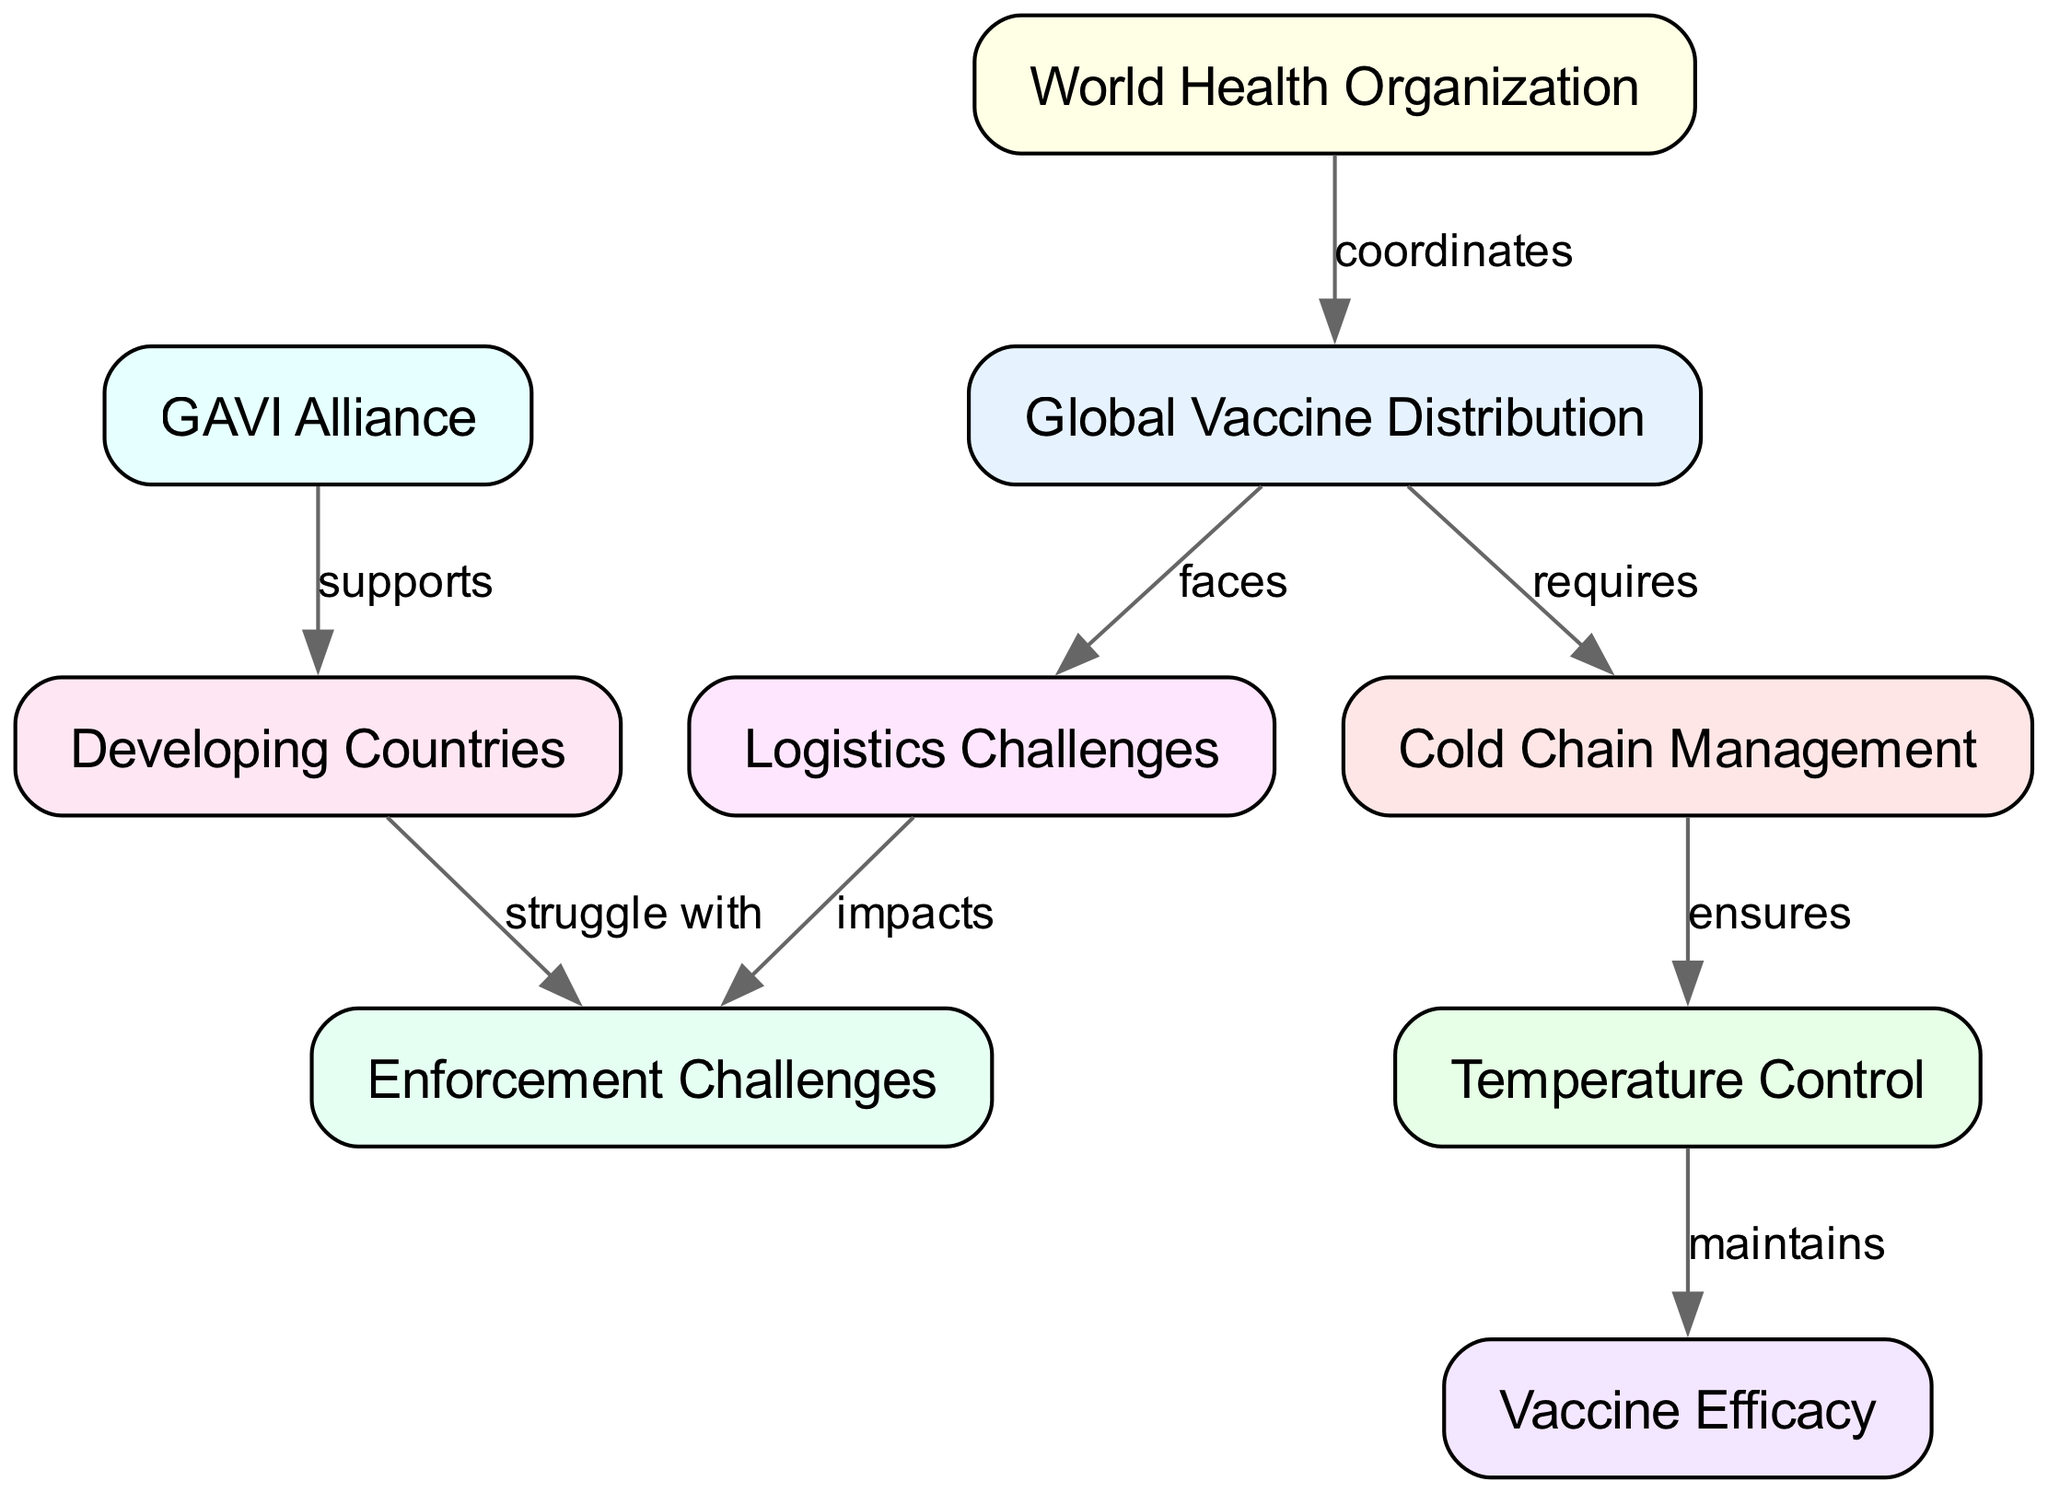What is the total number of nodes in this concept map? The diagram contains nodes such as Global Vaccine Distribution, Cold Chain Management, Temperature Control, Logistics Challenges, World Health Organization, GAVI Alliance, Developing Countries, Vaccine Efficacy, and Enforcement Challenges. By counting these, we find there are 9 nodes.
Answer: 9 Which organization coordinates global vaccine distribution? The edge from the World Health Organization to Global Vaccine Distribution indicates a direct relationship of coordination.
Answer: World Health Organization What does cold chain management ensure? The edge from Cold Chain Management to Temperature Control indicates that it ensures the appropriate temperature is maintained for vaccines.
Answer: Temperature Control How does logistics challenges impact enforcement? The edge from Logistics Challenges to Enforcement Challenges indicates that the difficulties faced in logistics have a direct impact on enforcement issues.
Answer: impacts Which organization supports vaccine distribution in developing countries? The edge from GAVI Alliance to Developing Countries shows that this organization provides support specifically for those countries in the context of vaccine distribution.
Answer: GAVI Alliance What maintains vaccine efficacy in transport? The edge from Temperature Control to Vaccine Efficacy indicates that maintaining the correct temperature is crucial for preserving the effectiveness of vaccines during distribution.
Answer: Temperature Control How many edges represent relationships in the concept map? By counting the connections shown by the edges among the nodes, we find there are 8 distinct relationships depicted in the diagram.
Answer: 8 Which two nodes are directly connected by the label "struggle with"? The edge from Developing Countries to Enforcement Challenges is labeled "struggle with," indicating a struggle faced by those countries regarding enforcement in vaccine distribution.
Answer: Enforcement Challenges What is the primary goal of cold chain management in vaccine distribution? The diagram shows that Cold Chain Management is primarily aimed at maintaining the required temperature for vaccine efficacy, thus ensuring successful vaccine delivery.
Answer: Vaccine Efficacy 